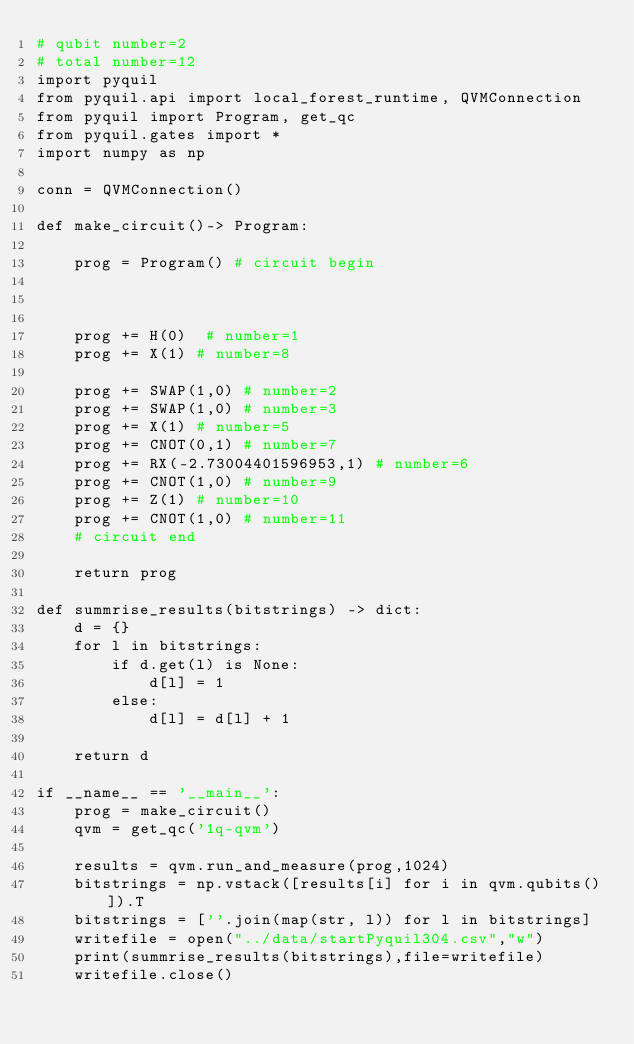<code> <loc_0><loc_0><loc_500><loc_500><_Python_># qubit number=2
# total number=12
import pyquil
from pyquil.api import local_forest_runtime, QVMConnection
from pyquil import Program, get_qc
from pyquil.gates import *
import numpy as np

conn = QVMConnection()

def make_circuit()-> Program:

    prog = Program() # circuit begin



    prog += H(0)  # number=1
    prog += X(1) # number=8

    prog += SWAP(1,0) # number=2
    prog += SWAP(1,0) # number=3
    prog += X(1) # number=5
    prog += CNOT(0,1) # number=7
    prog += RX(-2.73004401596953,1) # number=6
    prog += CNOT(1,0) # number=9
    prog += Z(1) # number=10
    prog += CNOT(1,0) # number=11
    # circuit end

    return prog

def summrise_results(bitstrings) -> dict:
    d = {}
    for l in bitstrings:
        if d.get(l) is None:
            d[l] = 1
        else:
            d[l] = d[l] + 1

    return d

if __name__ == '__main__':
    prog = make_circuit()
    qvm = get_qc('1q-qvm')

    results = qvm.run_and_measure(prog,1024)
    bitstrings = np.vstack([results[i] for i in qvm.qubits()]).T
    bitstrings = [''.join(map(str, l)) for l in bitstrings]
    writefile = open("../data/startPyquil304.csv","w")
    print(summrise_results(bitstrings),file=writefile)
    writefile.close()

</code> 